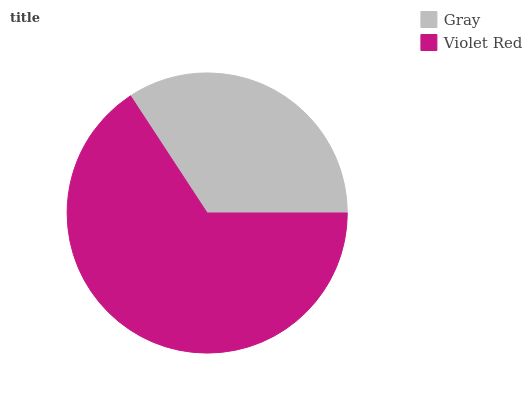Is Gray the minimum?
Answer yes or no. Yes. Is Violet Red the maximum?
Answer yes or no. Yes. Is Violet Red the minimum?
Answer yes or no. No. Is Violet Red greater than Gray?
Answer yes or no. Yes. Is Gray less than Violet Red?
Answer yes or no. Yes. Is Gray greater than Violet Red?
Answer yes or no. No. Is Violet Red less than Gray?
Answer yes or no. No. Is Violet Red the high median?
Answer yes or no. Yes. Is Gray the low median?
Answer yes or no. Yes. Is Gray the high median?
Answer yes or no. No. Is Violet Red the low median?
Answer yes or no. No. 